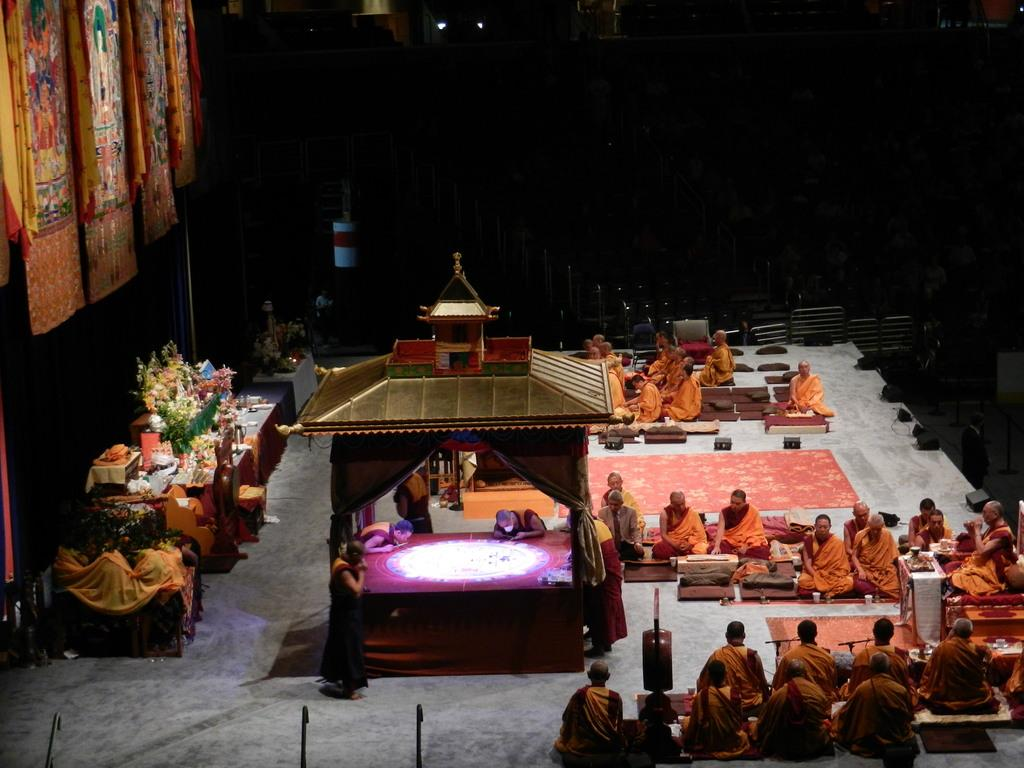What are the people in the image doing? There is a group of people sitting on the floor in the image. What type of material can be seen in the image? There are cloths in the image. What structure is visible in the image? There is a shed in the image. What else can be seen in the image besides the people, cloths, and shed? There are objects in the image. How would you describe the lighting in the image? The background of the image is dark. What type of kite is being flown in the image? There is no kite present in the image. What is the frame of the image made of? The frame of the image is not visible in the provided facts, as we are only given information about the contents of the image itself. 